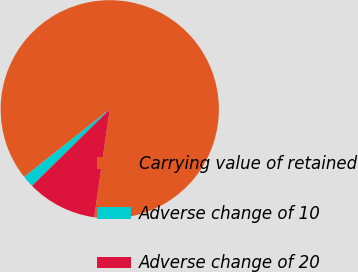Convert chart to OTSL. <chart><loc_0><loc_0><loc_500><loc_500><pie_chart><fcel>Carrying value of retained<fcel>Adverse change of 10<fcel>Adverse change of 20<nl><fcel>87.92%<fcel>1.73%<fcel>10.35%<nl></chart> 